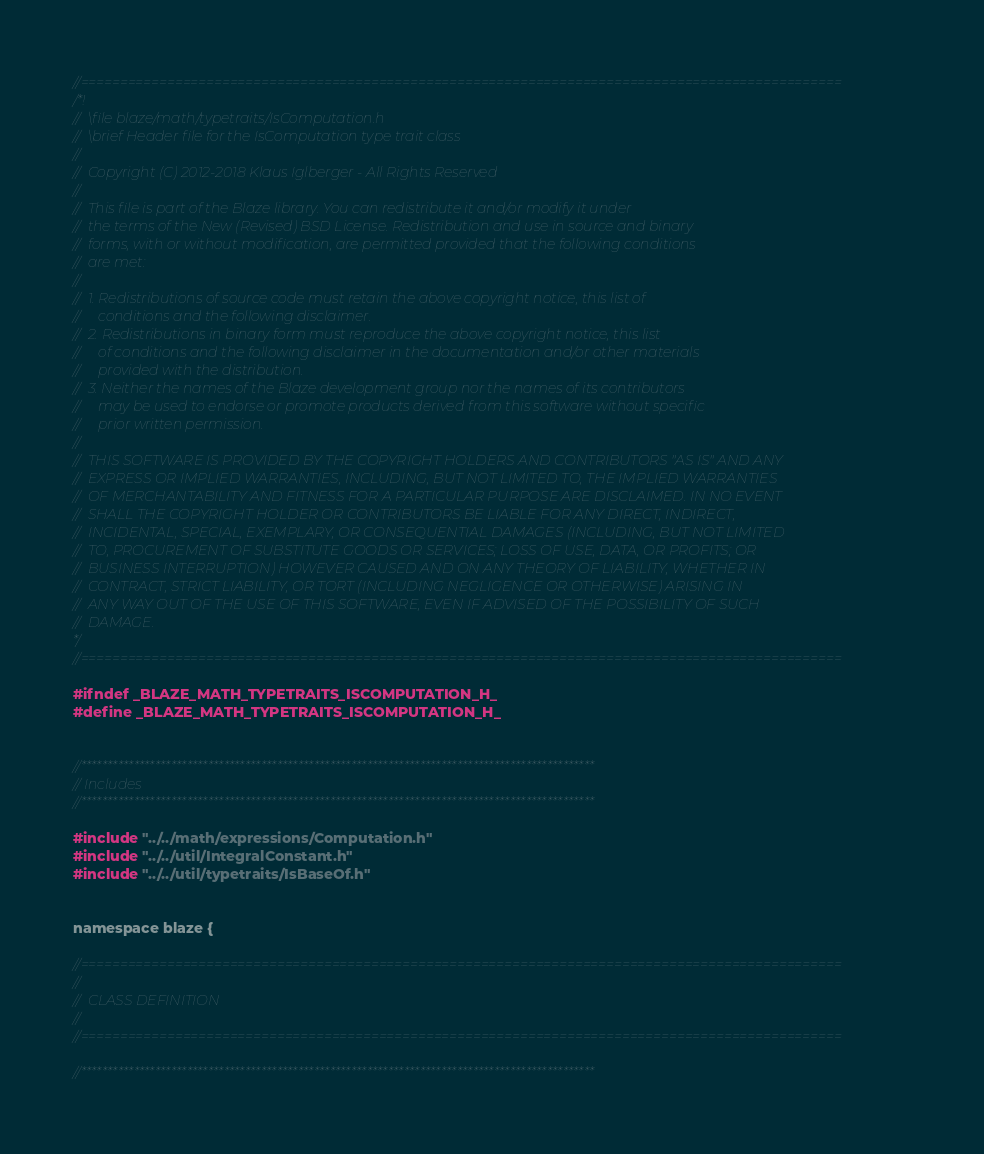<code> <loc_0><loc_0><loc_500><loc_500><_C_>//=================================================================================================
/*!
//  \file blaze/math/typetraits/IsComputation.h
//  \brief Header file for the IsComputation type trait class
//
//  Copyright (C) 2012-2018 Klaus Iglberger - All Rights Reserved
//
//  This file is part of the Blaze library. You can redistribute it and/or modify it under
//  the terms of the New (Revised) BSD License. Redistribution and use in source and binary
//  forms, with or without modification, are permitted provided that the following conditions
//  are met:
//
//  1. Redistributions of source code must retain the above copyright notice, this list of
//     conditions and the following disclaimer.
//  2. Redistributions in binary form must reproduce the above copyright notice, this list
//     of conditions and the following disclaimer in the documentation and/or other materials
//     provided with the distribution.
//  3. Neither the names of the Blaze development group nor the names of its contributors
//     may be used to endorse or promote products derived from this software without specific
//     prior written permission.
//
//  THIS SOFTWARE IS PROVIDED BY THE COPYRIGHT HOLDERS AND CONTRIBUTORS "AS IS" AND ANY
//  EXPRESS OR IMPLIED WARRANTIES, INCLUDING, BUT NOT LIMITED TO, THE IMPLIED WARRANTIES
//  OF MERCHANTABILITY AND FITNESS FOR A PARTICULAR PURPOSE ARE DISCLAIMED. IN NO EVENT
//  SHALL THE COPYRIGHT HOLDER OR CONTRIBUTORS BE LIABLE FOR ANY DIRECT, INDIRECT,
//  INCIDENTAL, SPECIAL, EXEMPLARY, OR CONSEQUENTIAL DAMAGES (INCLUDING, BUT NOT LIMITED
//  TO, PROCUREMENT OF SUBSTITUTE GOODS OR SERVICES; LOSS OF USE, DATA, OR PROFITS; OR
//  BUSINESS INTERRUPTION) HOWEVER CAUSED AND ON ANY THEORY OF LIABILITY, WHETHER IN
//  CONTRACT, STRICT LIABILITY, OR TORT (INCLUDING NEGLIGENCE OR OTHERWISE) ARISING IN
//  ANY WAY OUT OF THE USE OF THIS SOFTWARE, EVEN IF ADVISED OF THE POSSIBILITY OF SUCH
//  DAMAGE.
*/
//=================================================================================================

#ifndef _BLAZE_MATH_TYPETRAITS_ISCOMPUTATION_H_
#define _BLAZE_MATH_TYPETRAITS_ISCOMPUTATION_H_


//*************************************************************************************************
// Includes
//*************************************************************************************************

#include "../../math/expressions/Computation.h"
#include "../../util/IntegralConstant.h"
#include "../../util/typetraits/IsBaseOf.h"


namespace blaze {

//=================================================================================================
//
//  CLASS DEFINITION
//
//=================================================================================================

//*************************************************************************************************</code> 